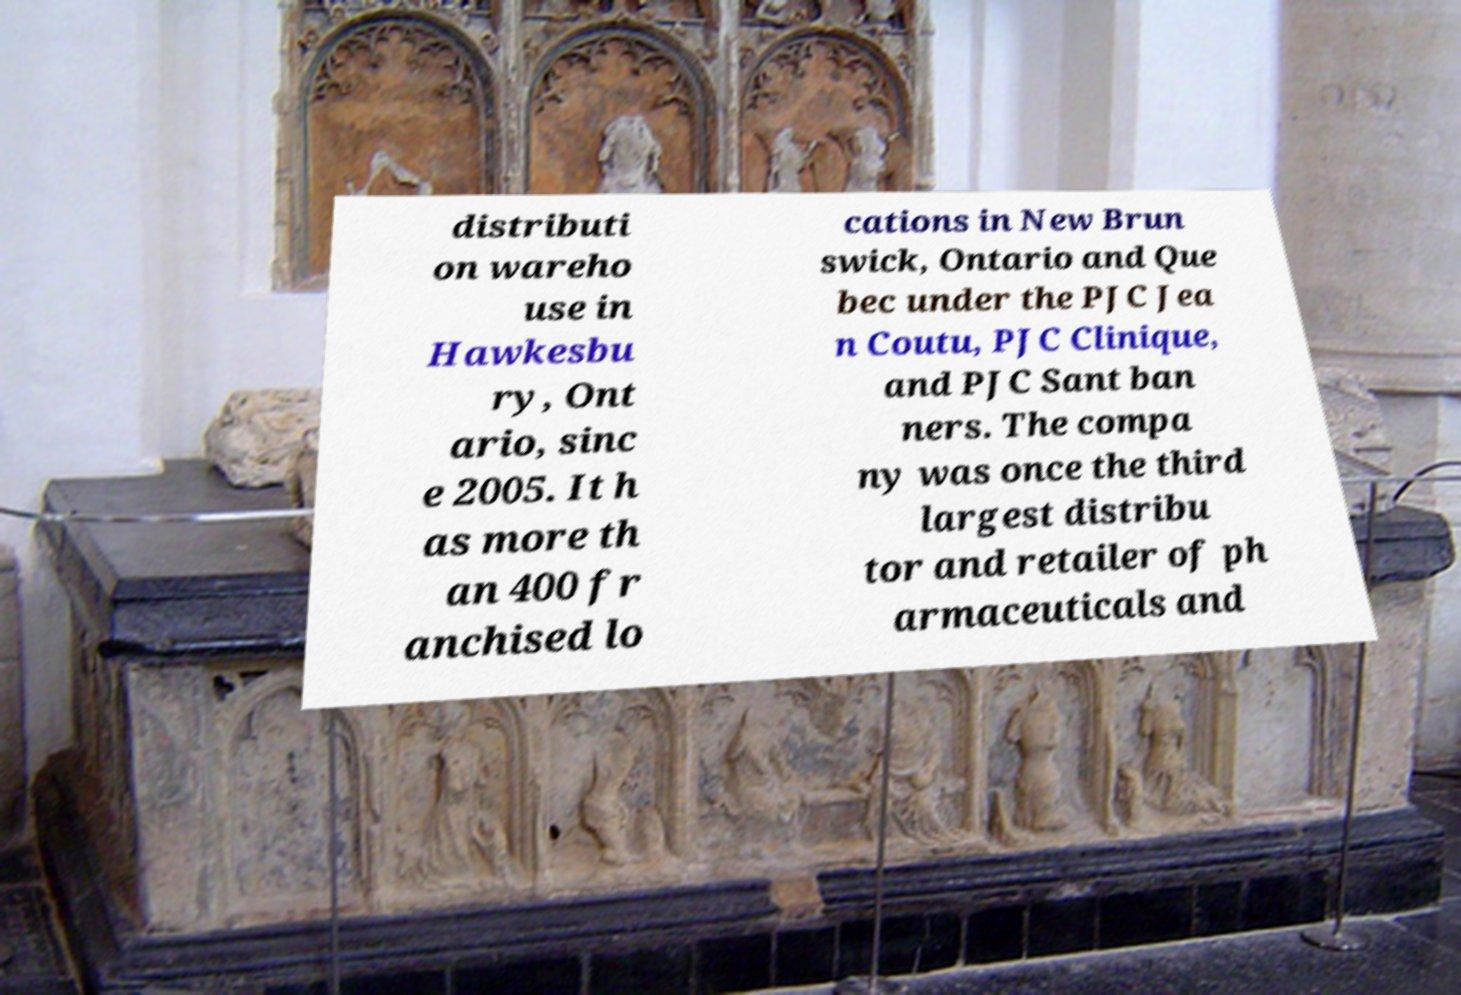Could you assist in decoding the text presented in this image and type it out clearly? distributi on wareho use in Hawkesbu ry, Ont ario, sinc e 2005. It h as more th an 400 fr anchised lo cations in New Brun swick, Ontario and Que bec under the PJC Jea n Coutu, PJC Clinique, and PJC Sant ban ners. The compa ny was once the third largest distribu tor and retailer of ph armaceuticals and 